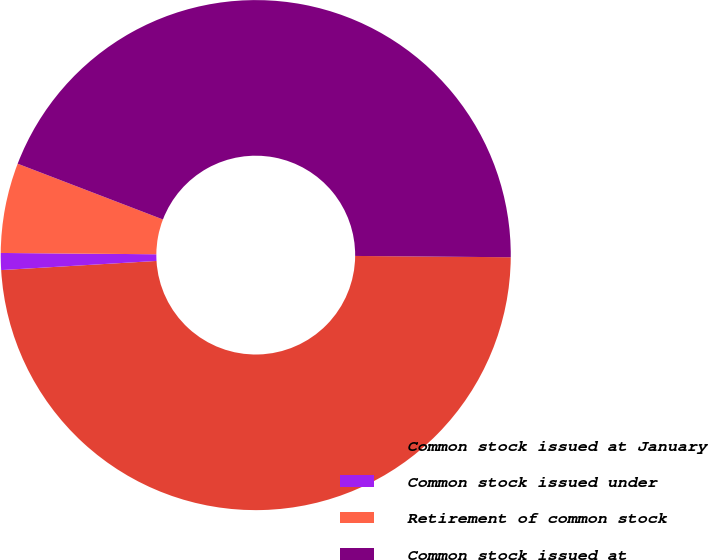Convert chart. <chart><loc_0><loc_0><loc_500><loc_500><pie_chart><fcel>Common stock issued at January<fcel>Common stock issued under<fcel>Retirement of common stock<fcel>Common stock issued at<nl><fcel>48.93%<fcel>1.07%<fcel>5.7%<fcel>44.3%<nl></chart> 